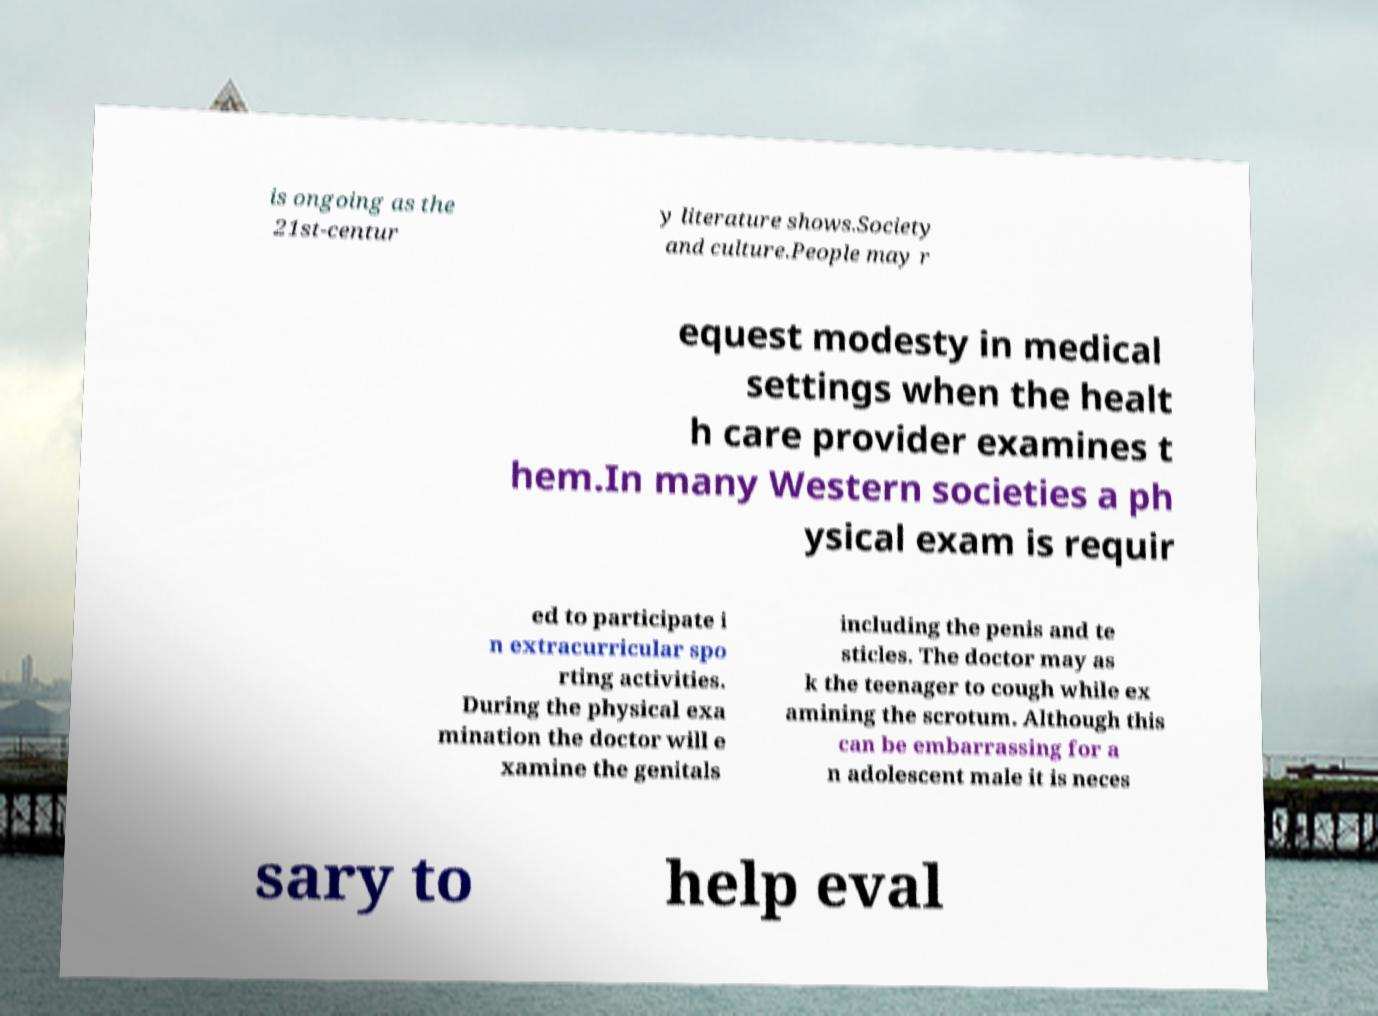Could you extract and type out the text from this image? is ongoing as the 21st-centur y literature shows.Society and culture.People may r equest modesty in medical settings when the healt h care provider examines t hem.In many Western societies a ph ysical exam is requir ed to participate i n extracurricular spo rting activities. During the physical exa mination the doctor will e xamine the genitals including the penis and te sticles. The doctor may as k the teenager to cough while ex amining the scrotum. Although this can be embarrassing for a n adolescent male it is neces sary to help eval 